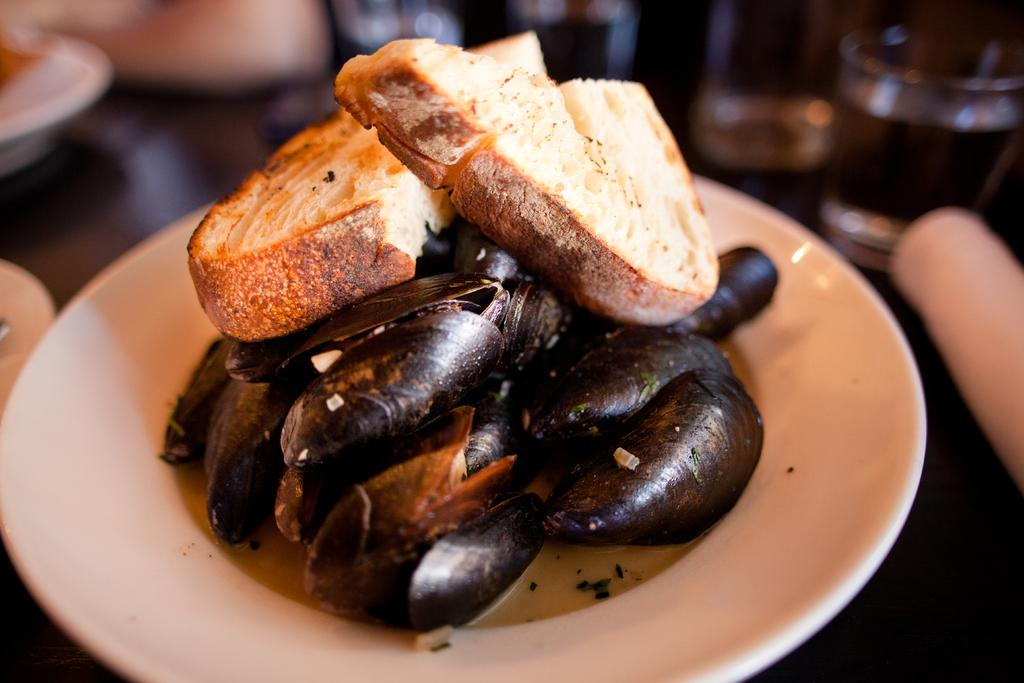What is on the plate that is visible in the image? The plate contains mussels. Are there any other food items on the plate? Yes, there are two pieces of bread on the plate. What can be seen in the background of the image? There is a glass of water in the background of the image. Where are the plates placed? The plates are placed on a table. What type of cactus can be seen in the image? There is no cactus present in the image. Can you describe the creature that is eating the mussels in the image? There is no creature present in the image; it is a plate of mussels and bread. 